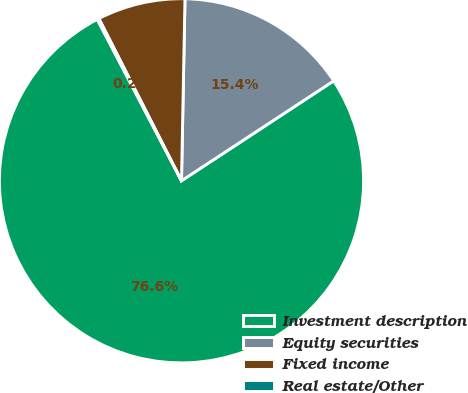Convert chart. <chart><loc_0><loc_0><loc_500><loc_500><pie_chart><fcel>Investment description<fcel>Equity securities<fcel>Fixed income<fcel>Real estate/Other<nl><fcel>76.59%<fcel>15.45%<fcel>7.8%<fcel>0.16%<nl></chart> 